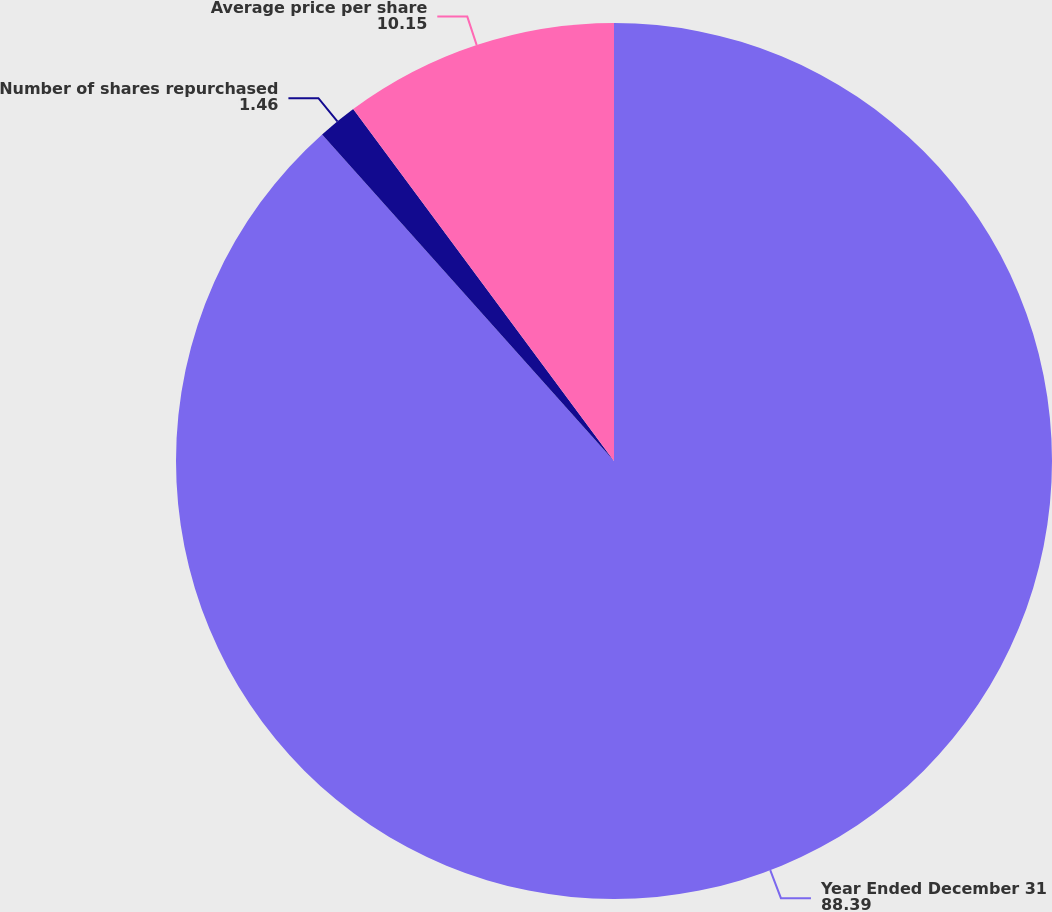Convert chart to OTSL. <chart><loc_0><loc_0><loc_500><loc_500><pie_chart><fcel>Year Ended December 31<fcel>Number of shares repurchased<fcel>Average price per share<nl><fcel>88.39%<fcel>1.46%<fcel>10.15%<nl></chart> 